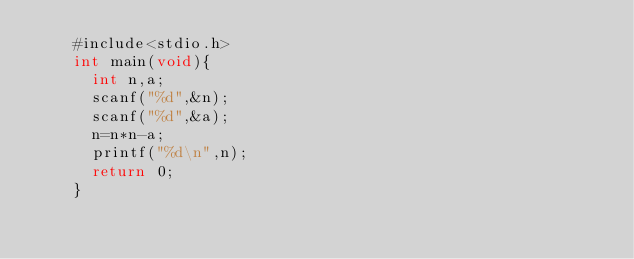Convert code to text. <code><loc_0><loc_0><loc_500><loc_500><_C_>    #include<stdio.h>
    int main(void){
      int n,a;
      scanf("%d",&n);
      scanf("%d",&a);
      n=n*n-a;
      printf("%d\n",n);
      return 0;
    }</code> 